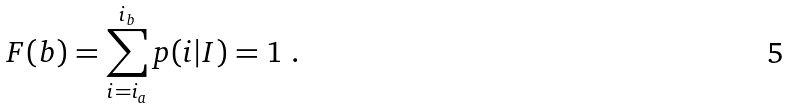<formula> <loc_0><loc_0><loc_500><loc_500>F ( b ) = \sum _ { i = i _ { a } } ^ { i _ { b } } p ( i | I ) = 1 \ .</formula> 